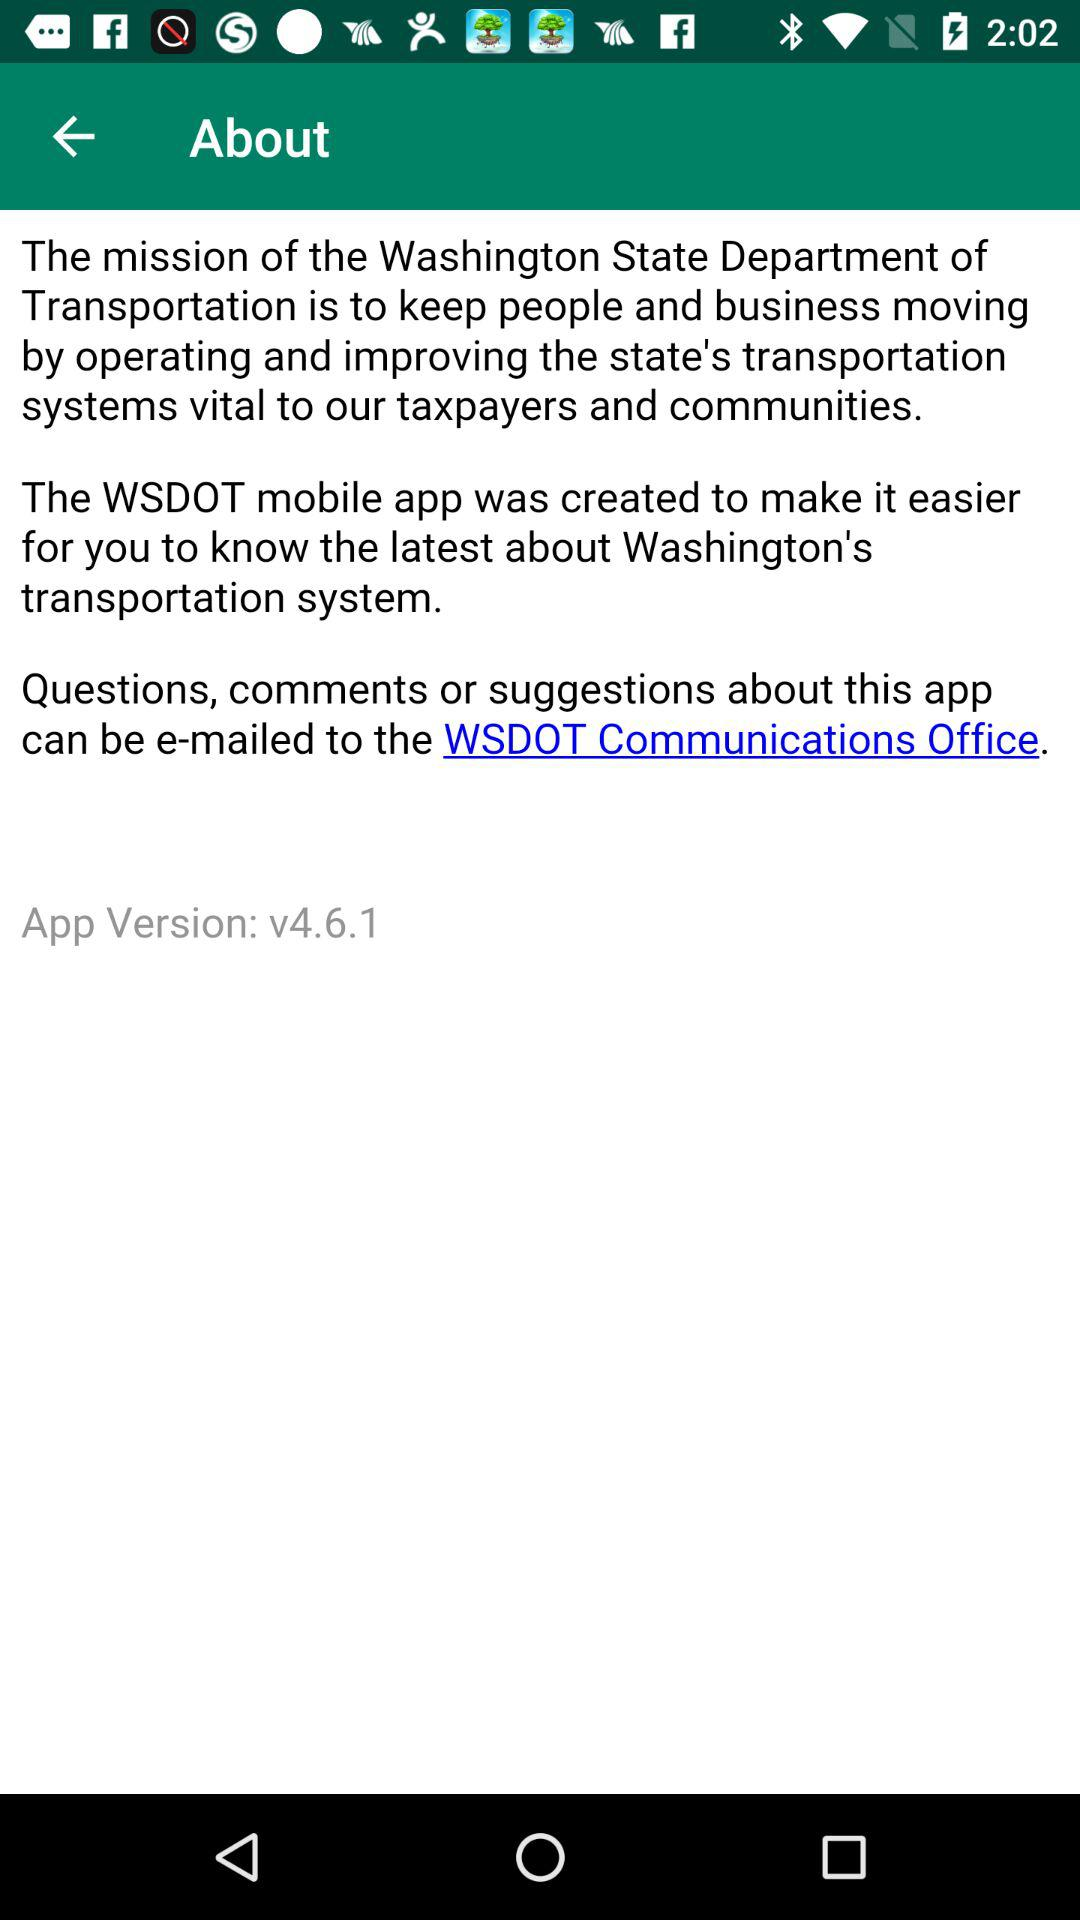What is the name of the application? The name of the application is "WSDOT". 